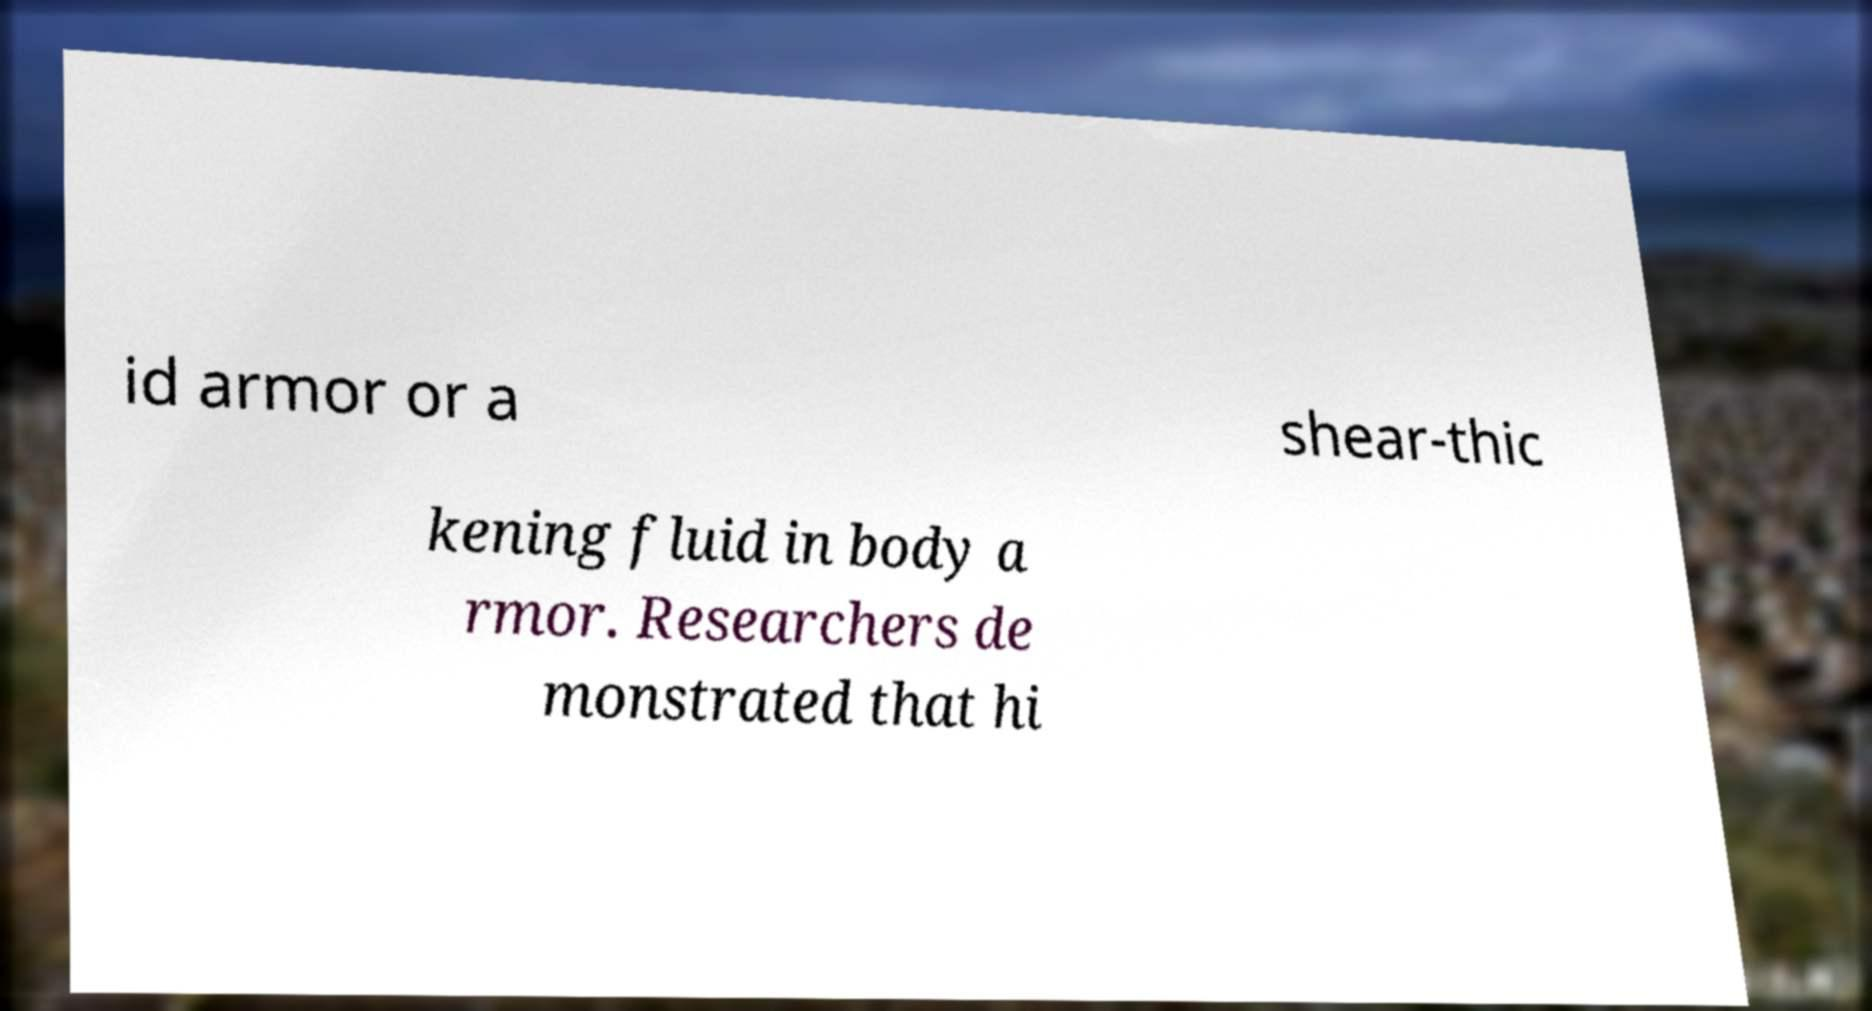I need the written content from this picture converted into text. Can you do that? id armor or a shear-thic kening fluid in body a rmor. Researchers de monstrated that hi 